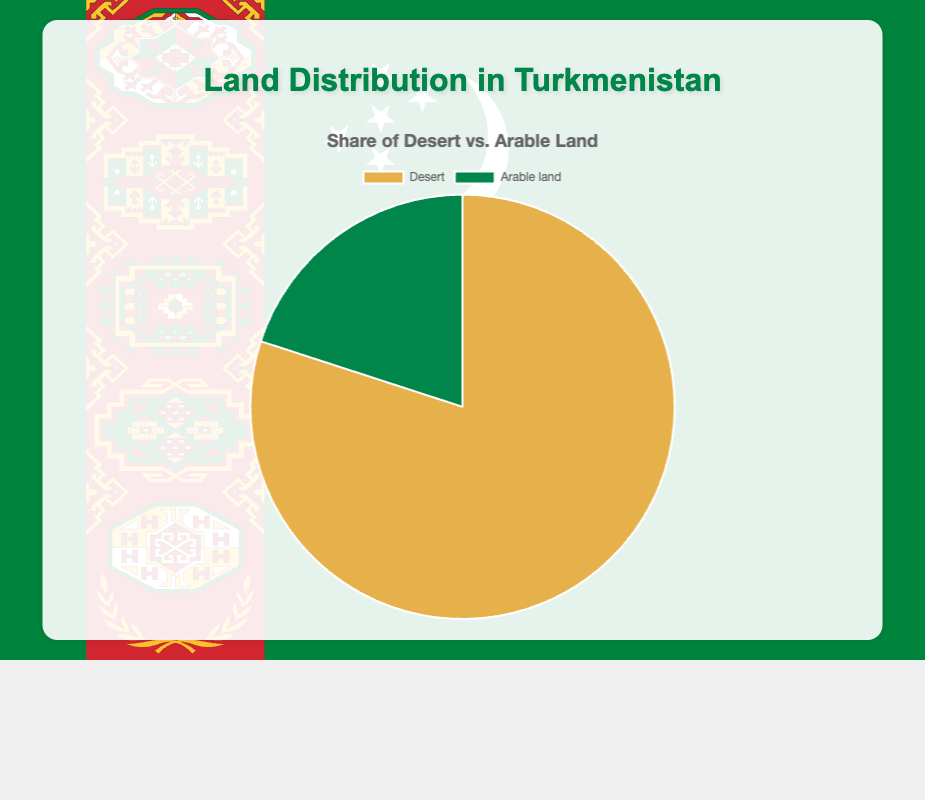What percentage of Turkmenistan's land is composed of desert? The pie chart shows that the desert portion is represented by the most significant segment. The desert percentage is labeled directly on this segment as 80%.
Answer: 80% What percentage of Turkmenistan's land is categorized as arable land? The pie chart shows that the arable land portion is represented by the smaller segment. The arable land percentage is labeled directly on this segment as 20%.
Answer: 20% Which type of land takes up a larger share of Turkmenistan's land area? By comparing the sizes of the segments, it is clear that the desert segment is much larger than the arable land segment. The percentages also confirm this with 80% desert and 20% arable land.
Answer: Desert How many times larger is the desert portion compared to the arable land portion? To determine how many times larger the desert portion is compared to the arable land portion, we divide the desert percentage by the arable land percentage. So, 80% divided by 20% equals 4.
Answer: 4 If the arable land segment were to increase by 10%, what would the new percentage be? Adding 10% to the current arable land percentage (20%) results in 20 + 10 = 30%.
Answer: 30% What fraction of Turkmenistan’s land is arable as compared to desert? The fraction can be found by comparing the percentages directly: arable land (20%) over desert land (80%). Simplifying this fraction (20/80) results in 1/4.
Answer: 1/4 Explain the color coding of the pie chart segments. The pie chart uses different colors to represent the two land categories. The desert portion is shown in a sandy yellow color, often associated with desert imagery. The arable land is shown in a green color, symbolizing fertile, cultivable land.
Answer: Sandy yellow for desert, green for arable land By what percentage would the desert percentage need to decrease for the arable land to become equal? To make desert and arable land equal, each should be 50%. The desert portion is currently 80%, so it would need to decrease by 80% - 50% = 30%.
Answer: 30% What is the combined percentage of desert and arable land? The total percentage represented in the pie chart should add up to 100% because it covers the entire composition of the land in Turkmenistan. 80% (desert) + 20% (arable land) = 100%.
Answer: 100% 